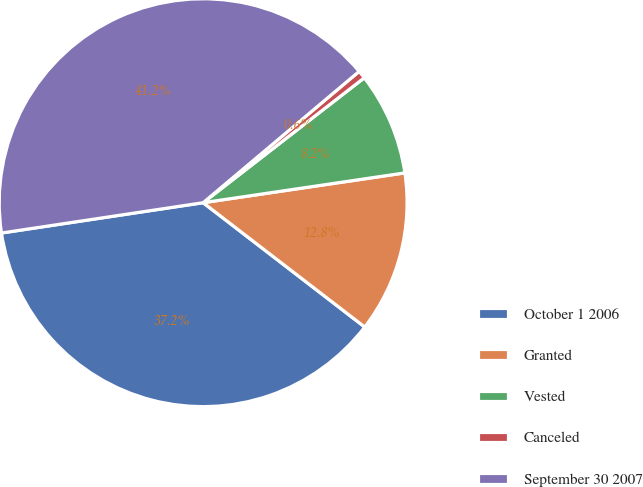Convert chart. <chart><loc_0><loc_0><loc_500><loc_500><pie_chart><fcel>October 1 2006<fcel>Granted<fcel>Vested<fcel>Canceled<fcel>September 30 2007<nl><fcel>37.19%<fcel>12.77%<fcel>8.16%<fcel>0.64%<fcel>41.24%<nl></chart> 